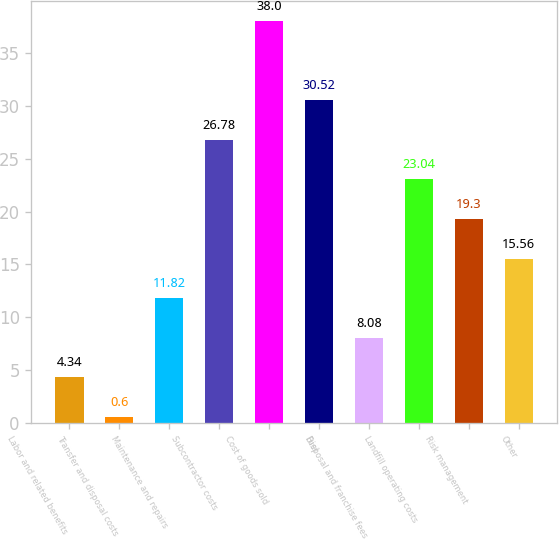<chart> <loc_0><loc_0><loc_500><loc_500><bar_chart><fcel>Labor and related benefits<fcel>Transfer and disposal costs<fcel>Maintenance and repairs<fcel>Subcontractor costs<fcel>Cost of goods sold<fcel>Fuel<fcel>Disposal and franchise fees<fcel>Landfill operating costs<fcel>Risk management<fcel>Other<nl><fcel>4.34<fcel>0.6<fcel>11.82<fcel>26.78<fcel>38<fcel>30.52<fcel>8.08<fcel>23.04<fcel>19.3<fcel>15.56<nl></chart> 